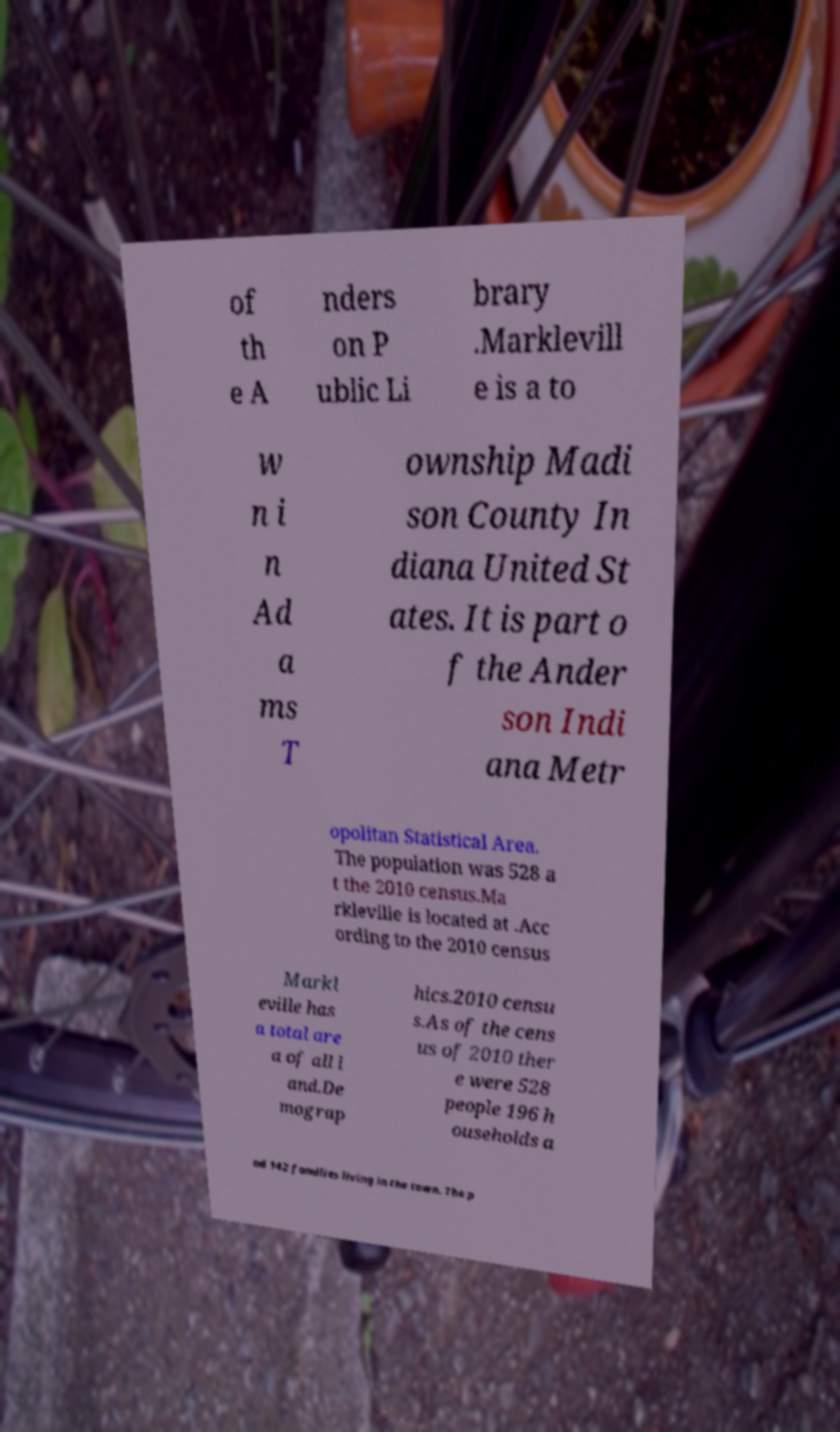For documentation purposes, I need the text within this image transcribed. Could you provide that? of th e A nders on P ublic Li brary .Marklevill e is a to w n i n Ad a ms T ownship Madi son County In diana United St ates. It is part o f the Ander son Indi ana Metr opolitan Statistical Area. The population was 528 a t the 2010 census.Ma rkleville is located at .Acc ording to the 2010 census Markl eville has a total are a of all l and.De mograp hics.2010 censu s.As of the cens us of 2010 ther e were 528 people 196 h ouseholds a nd 142 families living in the town. The p 